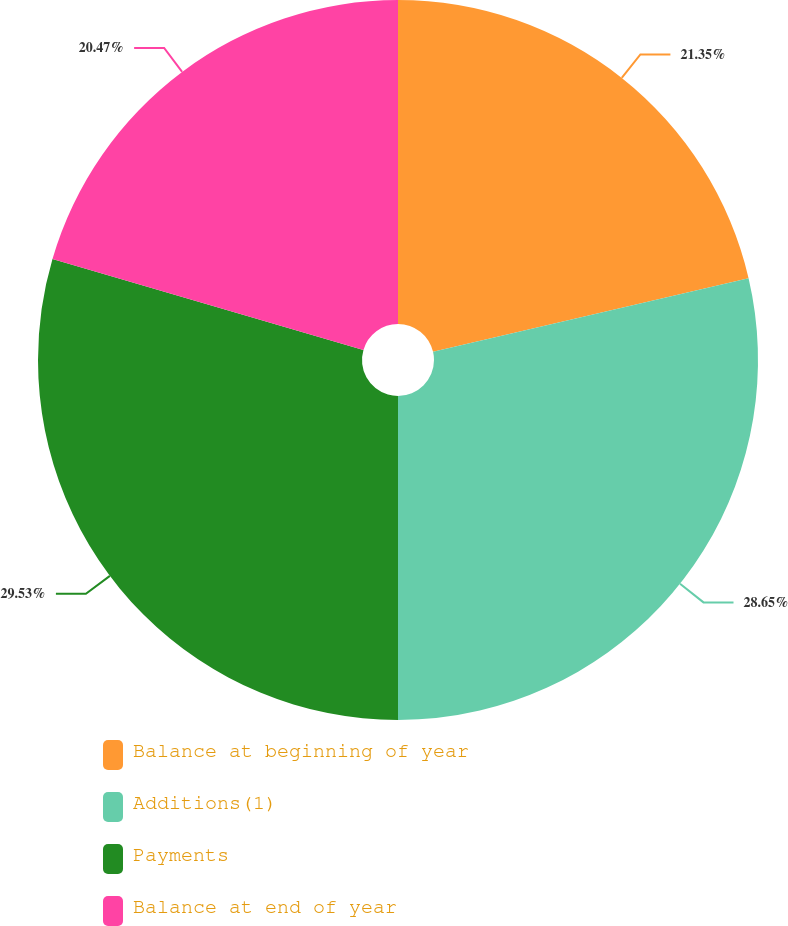Convert chart. <chart><loc_0><loc_0><loc_500><loc_500><pie_chart><fcel>Balance at beginning of year<fcel>Additions(1)<fcel>Payments<fcel>Balance at end of year<nl><fcel>21.35%<fcel>28.65%<fcel>29.53%<fcel>20.47%<nl></chart> 